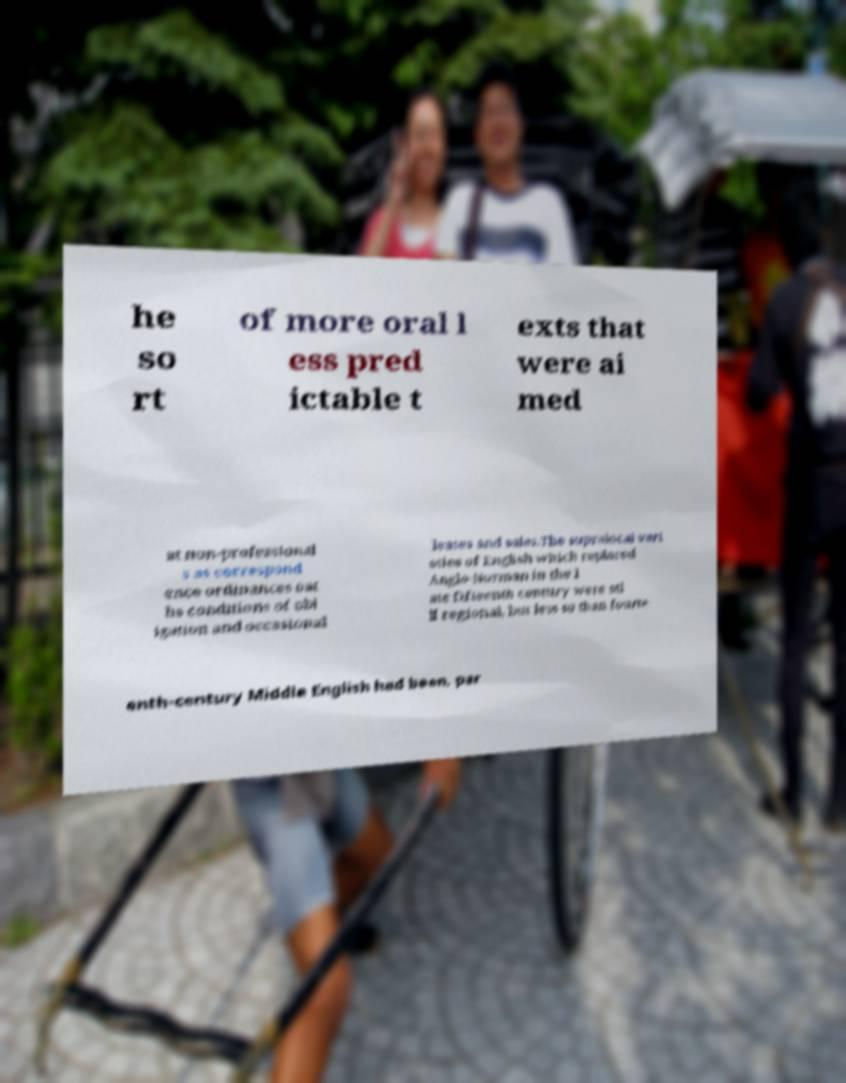Could you assist in decoding the text presented in this image and type it out clearly? he so rt of more oral l ess pred ictable t exts that were ai med at non-professional s as correspond ence ordinances oat hs conditions of obl igation and occasional leases and sales.The supralocal vari eties of English which replaced Anglo-Norman in the l ate fifteenth century were sti ll regional, but less so than fourte enth-century Middle English had been, par 